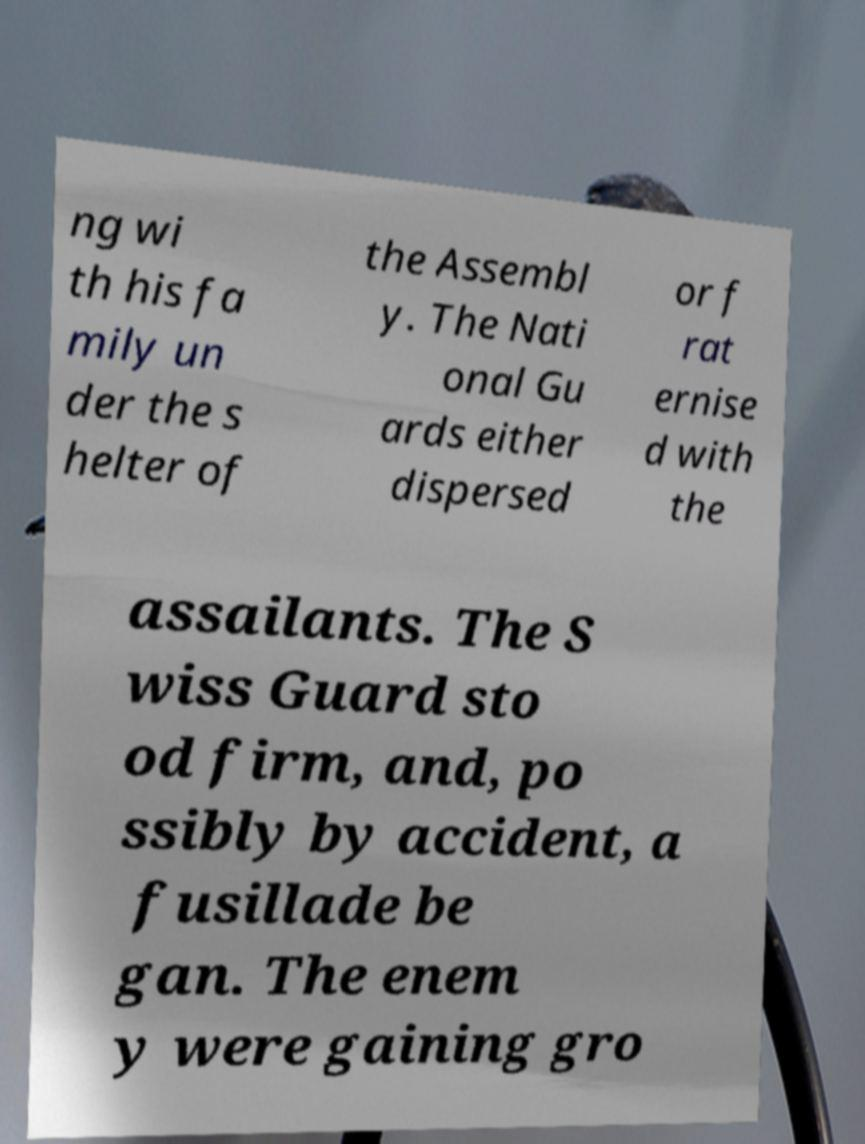What messages or text are displayed in this image? I need them in a readable, typed format. ng wi th his fa mily un der the s helter of the Assembl y. The Nati onal Gu ards either dispersed or f rat ernise d with the assailants. The S wiss Guard sto od firm, and, po ssibly by accident, a fusillade be gan. The enem y were gaining gro 